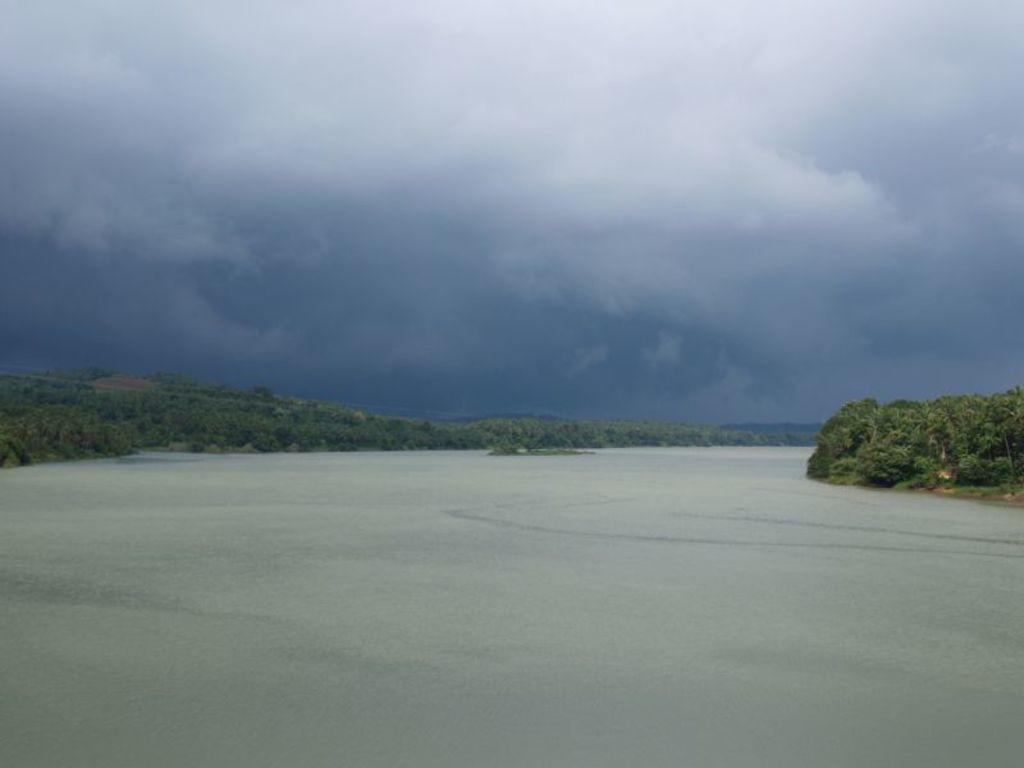What type of vegetation can be seen in the image? There are trees in the image. What natural element is visible in the image besides the trees? There is water visible in the image. What can be seen in the background of the image? The sky is visible in the background of the image. What is the condition of the sky in the image? Clouds are present in the sky. What type of work is the girl doing in the image? There is no girl present in the image, and therefore no work can be observed. What is the girl's desire in the image? There is no girl present in the image, and therefore no desire can be determined. 